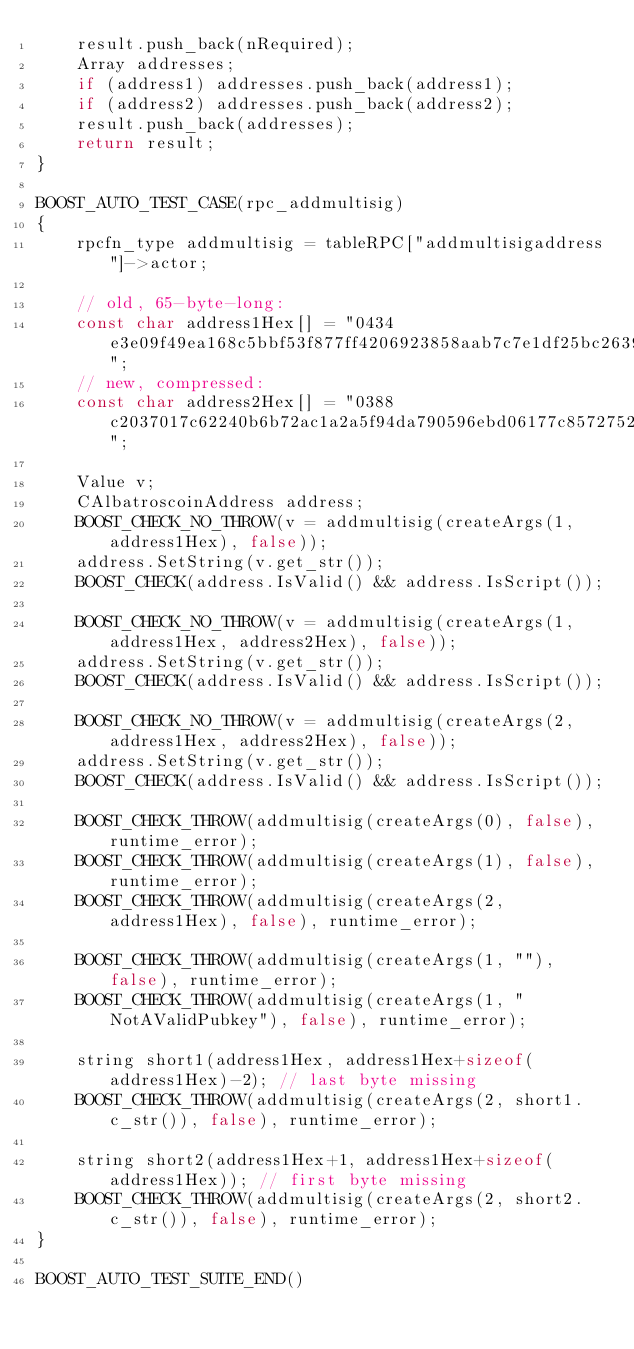<code> <loc_0><loc_0><loc_500><loc_500><_C++_>    result.push_back(nRequired);
    Array addresses;
    if (address1) addresses.push_back(address1);
    if (address2) addresses.push_back(address2);
    result.push_back(addresses);
    return result;
}

BOOST_AUTO_TEST_CASE(rpc_addmultisig)
{
    rpcfn_type addmultisig = tableRPC["addmultisigaddress"]->actor;

    // old, 65-byte-long:
    const char address1Hex[] = "0434e3e09f49ea168c5bbf53f877ff4206923858aab7c7e1df25bc263978107c95e35065a27ef6f1b27222db0ec97e0e895eaca603d3ee0d4c060ce3d8a00286c8";
    // new, compressed:
    const char address2Hex[] = "0388c2037017c62240b6b72ac1a2a5f94da790596ebd06177c8572752922165cb4";

    Value v;
    CAlbatroscoinAddress address;
    BOOST_CHECK_NO_THROW(v = addmultisig(createArgs(1, address1Hex), false));
    address.SetString(v.get_str());
    BOOST_CHECK(address.IsValid() && address.IsScript());

    BOOST_CHECK_NO_THROW(v = addmultisig(createArgs(1, address1Hex, address2Hex), false));
    address.SetString(v.get_str());
    BOOST_CHECK(address.IsValid() && address.IsScript());

    BOOST_CHECK_NO_THROW(v = addmultisig(createArgs(2, address1Hex, address2Hex), false));
    address.SetString(v.get_str());
    BOOST_CHECK(address.IsValid() && address.IsScript());

    BOOST_CHECK_THROW(addmultisig(createArgs(0), false), runtime_error);
    BOOST_CHECK_THROW(addmultisig(createArgs(1), false), runtime_error);
    BOOST_CHECK_THROW(addmultisig(createArgs(2, address1Hex), false), runtime_error);

    BOOST_CHECK_THROW(addmultisig(createArgs(1, ""), false), runtime_error);
    BOOST_CHECK_THROW(addmultisig(createArgs(1, "NotAValidPubkey"), false), runtime_error);

    string short1(address1Hex, address1Hex+sizeof(address1Hex)-2); // last byte missing
    BOOST_CHECK_THROW(addmultisig(createArgs(2, short1.c_str()), false), runtime_error);

    string short2(address1Hex+1, address1Hex+sizeof(address1Hex)); // first byte missing
    BOOST_CHECK_THROW(addmultisig(createArgs(2, short2.c_str()), false), runtime_error);
}

BOOST_AUTO_TEST_SUITE_END()
</code> 